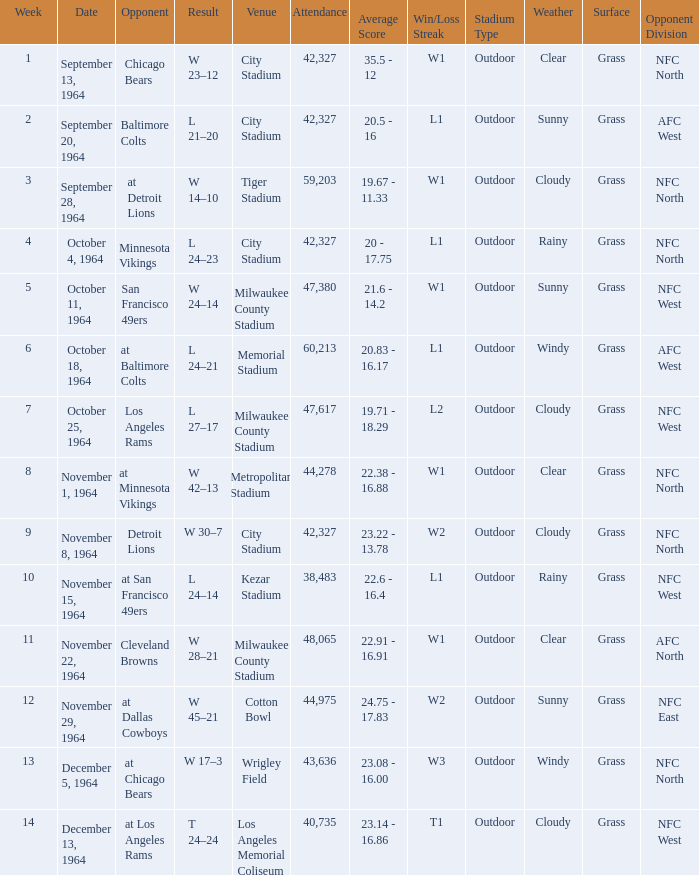What is the average week of the game on November 22, 1964 attended by 48,065? None. 